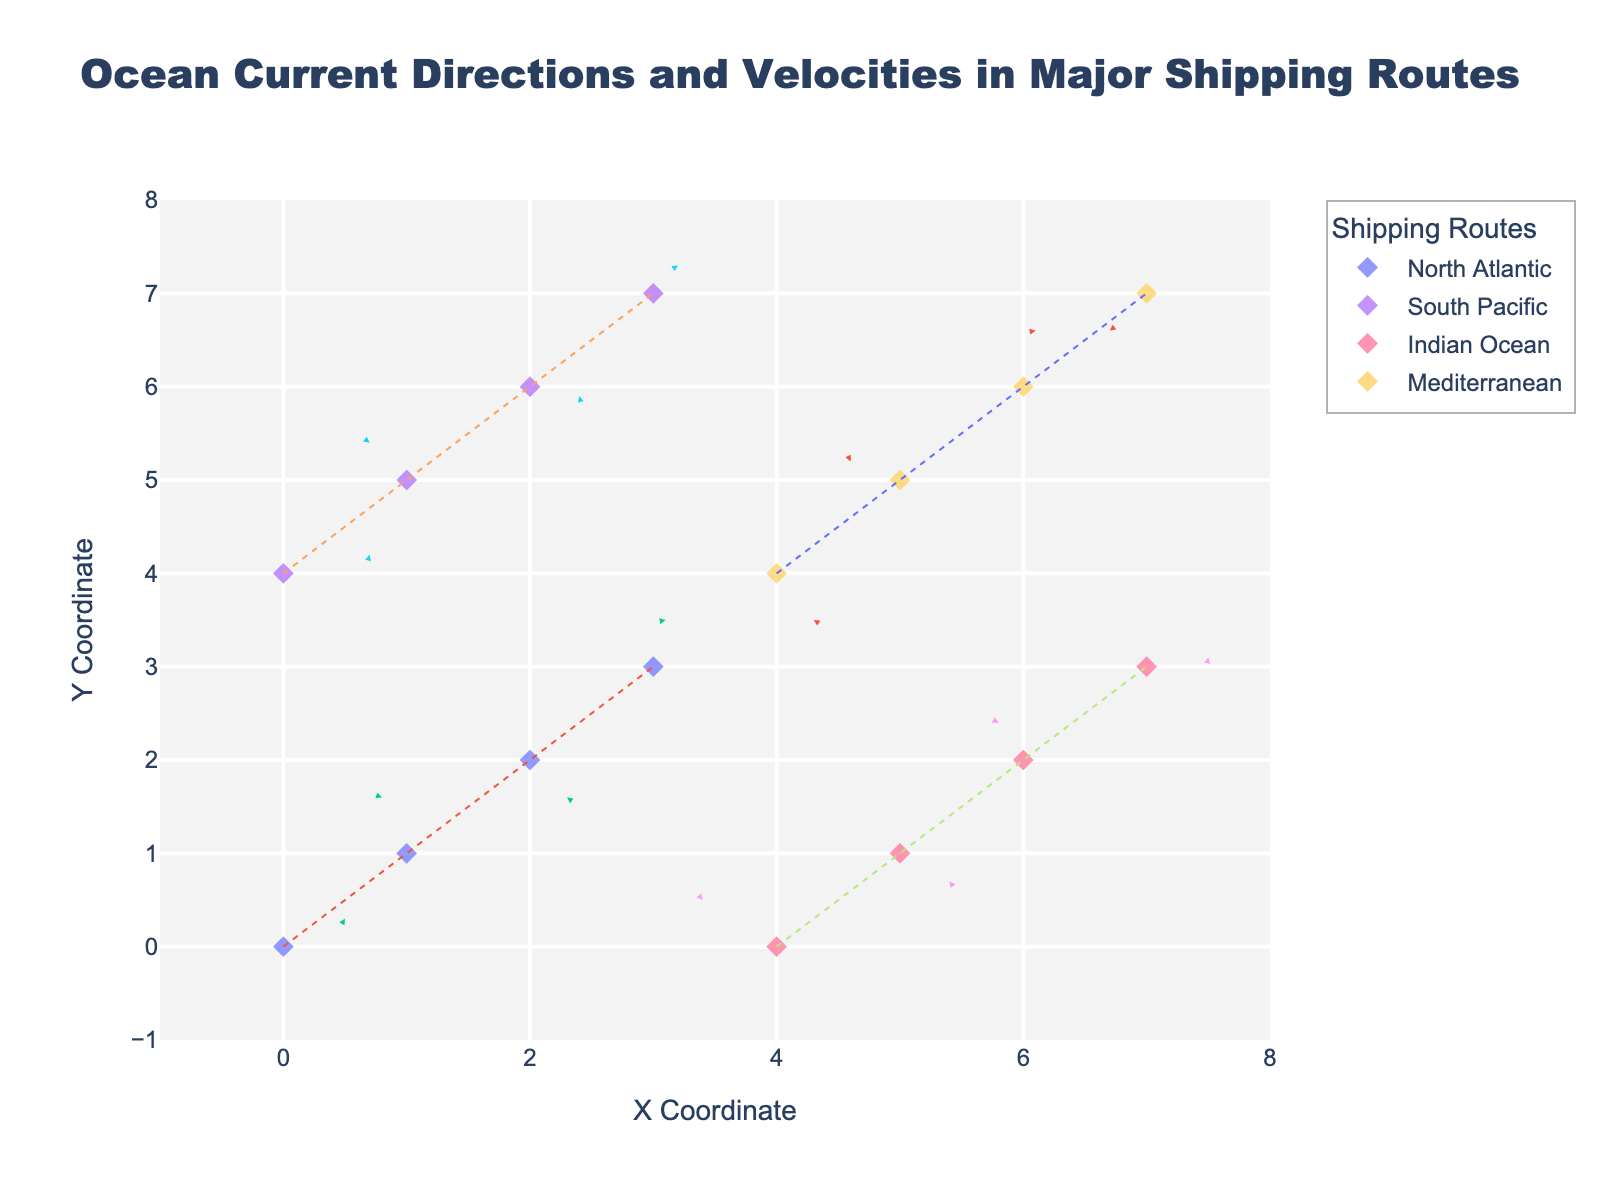What's the title of the figure? The title of the figure is usually placed at the top and is majority of the time more prominent in size and bolding compared to other texts within the figure. In this case, it combines the context of ocean currents and shipping routes.
Answer: Ocean Current Directions and Velocities in Major Shipping Routes How many major shipping routes are represented in the figure? The legend at the right side of the figure lists all the unique shipping routes being visualized. By counting these entries, you can determine the number of shipping routes.
Answer: 4 What are the X and Y coordinates for the point with the highest velocity in the North Atlantic route? To find the point with the highest velocity, you need to calculate the vector magnitude (√(u² + v²)) for each point in the North Atlantic route and compare them. The point with the highest magnitude has the highest velocity. By computing the magnitudes: (0.5² + 0.3²) = 0.34, (−0.2² + 0.6²) = 0.4, (0.3² + −0.4²) = 0.25, (0.1² + 0.5²) = 0.26. The highest is 0.4 at coordinates (1, 1).
Answer: (1, 1) In which shipping route does the current at the coordinate (5, 5) occur? To find this, refer to the hover information or directly find the point on the figure labeled at coordinate (5, 5). The label there indicates the respective shipping route.
Answer: Mediterranean What's the average velocity of the currents in the Indian Ocean route? Calculate the velocity magnitude for each point in the Indian Ocean route using √(u² + v²), then find the average of these magnitudes. The magnitudes are: (−0.6² + 0.5²) = 0.61, (0.4² + −0.3²) = 0.25, (−0.2² + 0.4²) = 0.2, (0.5² + 0.1²) = 0.26. So, the average is (0.61 + 0.25 + 0.2 + 0.26) / 4 ≈ 0.33.
Answer: ~0.33 Which route has the most visually diverse set of current directions? This is determined by observing the arrows' orientations and assessing the variety in their direction within the plotted routes. The route that appears to have arrows pointing in the most distinct directions is the one with the most diverse current directions.
Answer: Mediterranean What is the range of X values covered by the plotted points? This involves identifying the minimum and maximum X coordinates among all the points in the figure. Here it spans from the smallest X coordinate to the largest. The minimum X coordinate is 0 and the maximum is 7.
Answer: 0 to 7 Which route has the greatest change in Y direction from start to end? By examining the difference in Y coordinates from the starting point to the ending point within each route, we can determine the route with the largest change. Calculate the absolute change (end Y - start Y) for each route: North Atlantic (3 - 0) = 3, South Pacific (7 - 4) = 3, Indian Ocean (3 - 0) = 1, Mediterranean (7 - 4) = 3. Since North Atlantic, South Pacific, and Mediterranean routes have the equal greatest change, select any as the largest.
Answer: North Atlantic / South Pacific / Mediterranean 